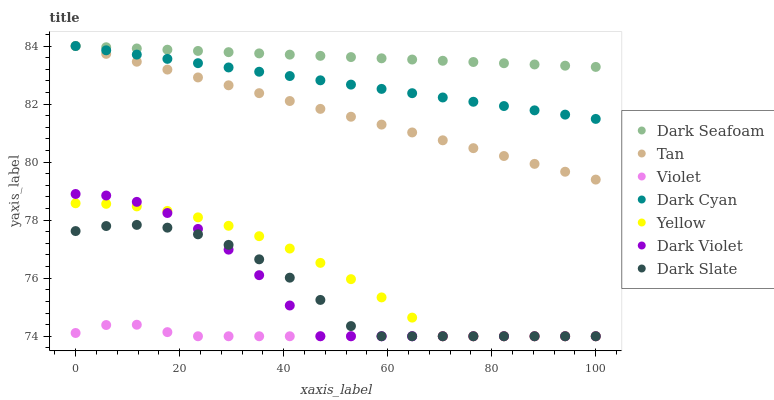Does Violet have the minimum area under the curve?
Answer yes or no. Yes. Does Dark Seafoam have the maximum area under the curve?
Answer yes or no. Yes. Does Dark Slate have the minimum area under the curve?
Answer yes or no. No. Does Dark Slate have the maximum area under the curve?
Answer yes or no. No. Is Tan the smoothest?
Answer yes or no. Yes. Is Dark Violet the roughest?
Answer yes or no. Yes. Is Dark Slate the smoothest?
Answer yes or no. No. Is Dark Slate the roughest?
Answer yes or no. No. Does Dark Violet have the lowest value?
Answer yes or no. Yes. Does Dark Seafoam have the lowest value?
Answer yes or no. No. Does Tan have the highest value?
Answer yes or no. Yes. Does Dark Slate have the highest value?
Answer yes or no. No. Is Dark Violet less than Dark Cyan?
Answer yes or no. Yes. Is Dark Seafoam greater than Violet?
Answer yes or no. Yes. Does Dark Seafoam intersect Dark Cyan?
Answer yes or no. Yes. Is Dark Seafoam less than Dark Cyan?
Answer yes or no. No. Is Dark Seafoam greater than Dark Cyan?
Answer yes or no. No. Does Dark Violet intersect Dark Cyan?
Answer yes or no. No. 